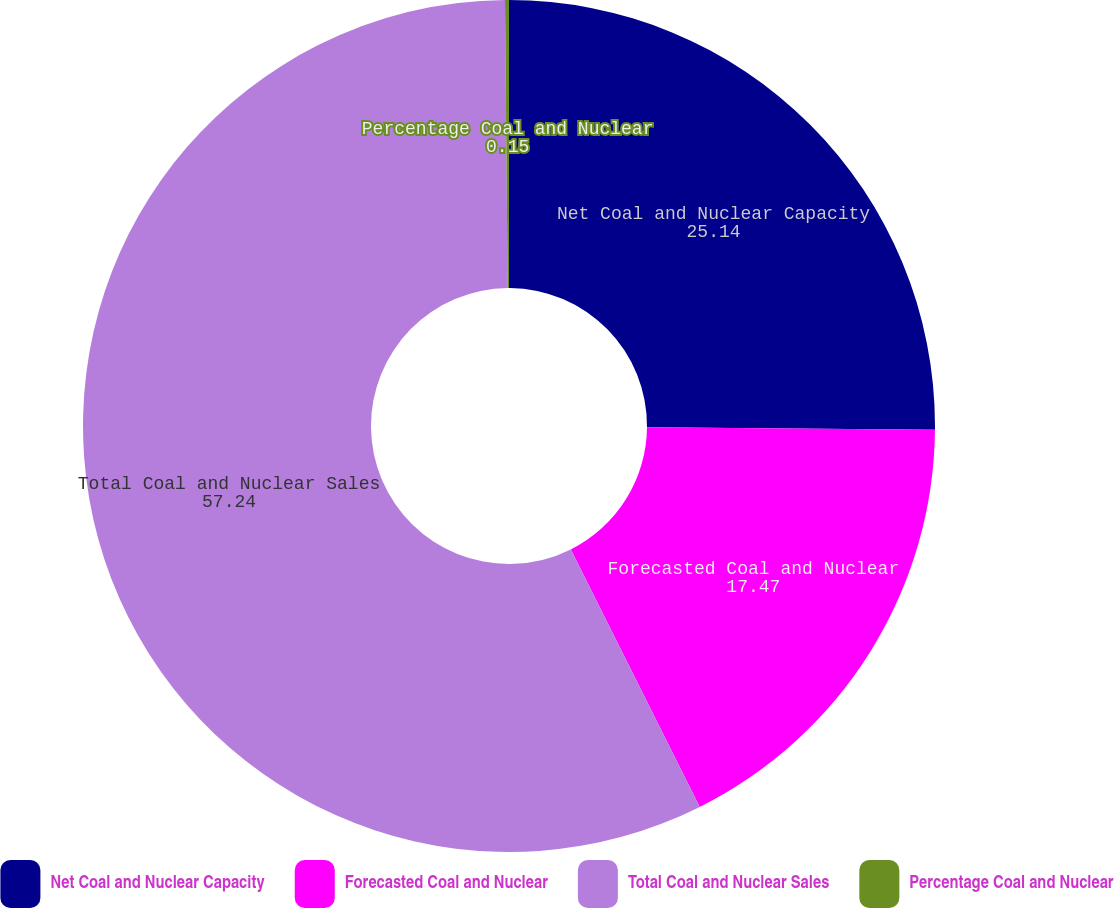Convert chart. <chart><loc_0><loc_0><loc_500><loc_500><pie_chart><fcel>Net Coal and Nuclear Capacity<fcel>Forecasted Coal and Nuclear<fcel>Total Coal and Nuclear Sales<fcel>Percentage Coal and Nuclear<nl><fcel>25.14%<fcel>17.47%<fcel>57.24%<fcel>0.15%<nl></chart> 